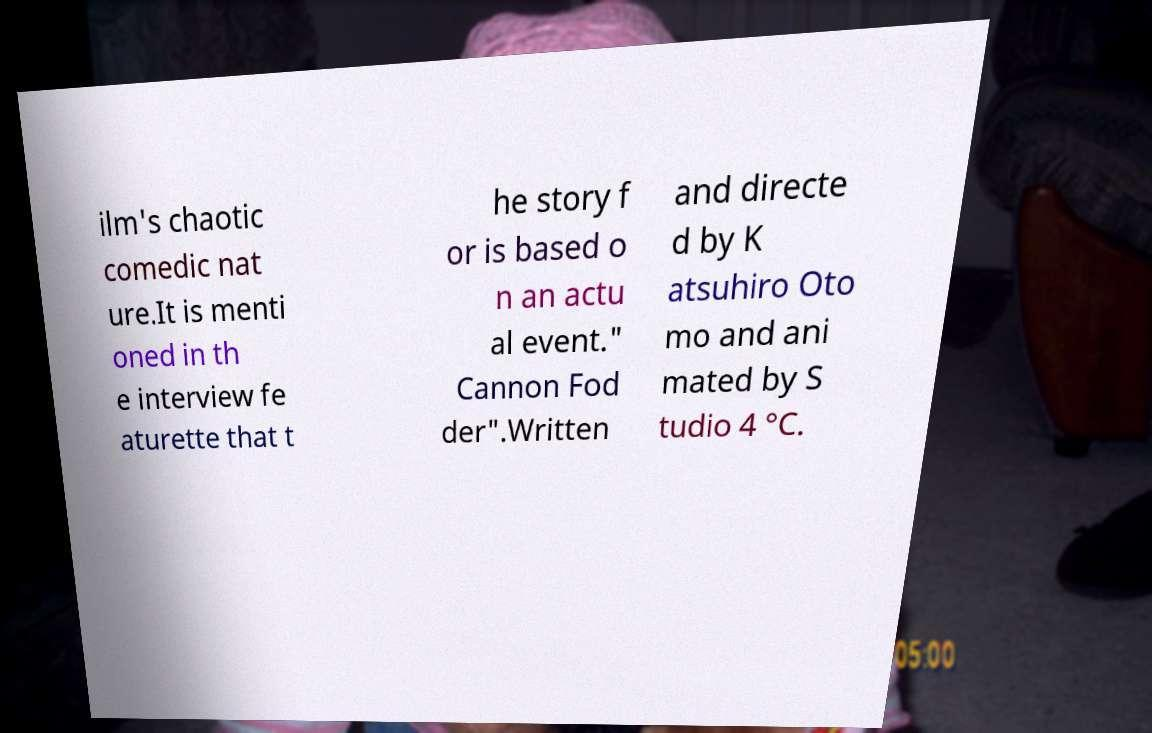Can you accurately transcribe the text from the provided image for me? ilm's chaotic comedic nat ure.It is menti oned in th e interview fe aturette that t he story f or is based o n an actu al event." Cannon Fod der".Written and directe d by K atsuhiro Oto mo and ani mated by S tudio 4 °C. 